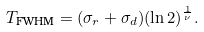<formula> <loc_0><loc_0><loc_500><loc_500>T _ { \text {FWHM} } = ( \sigma _ { r } + \sigma _ { d } ) ( \ln 2 ) ^ { \frac { 1 } { \nu } } .</formula> 